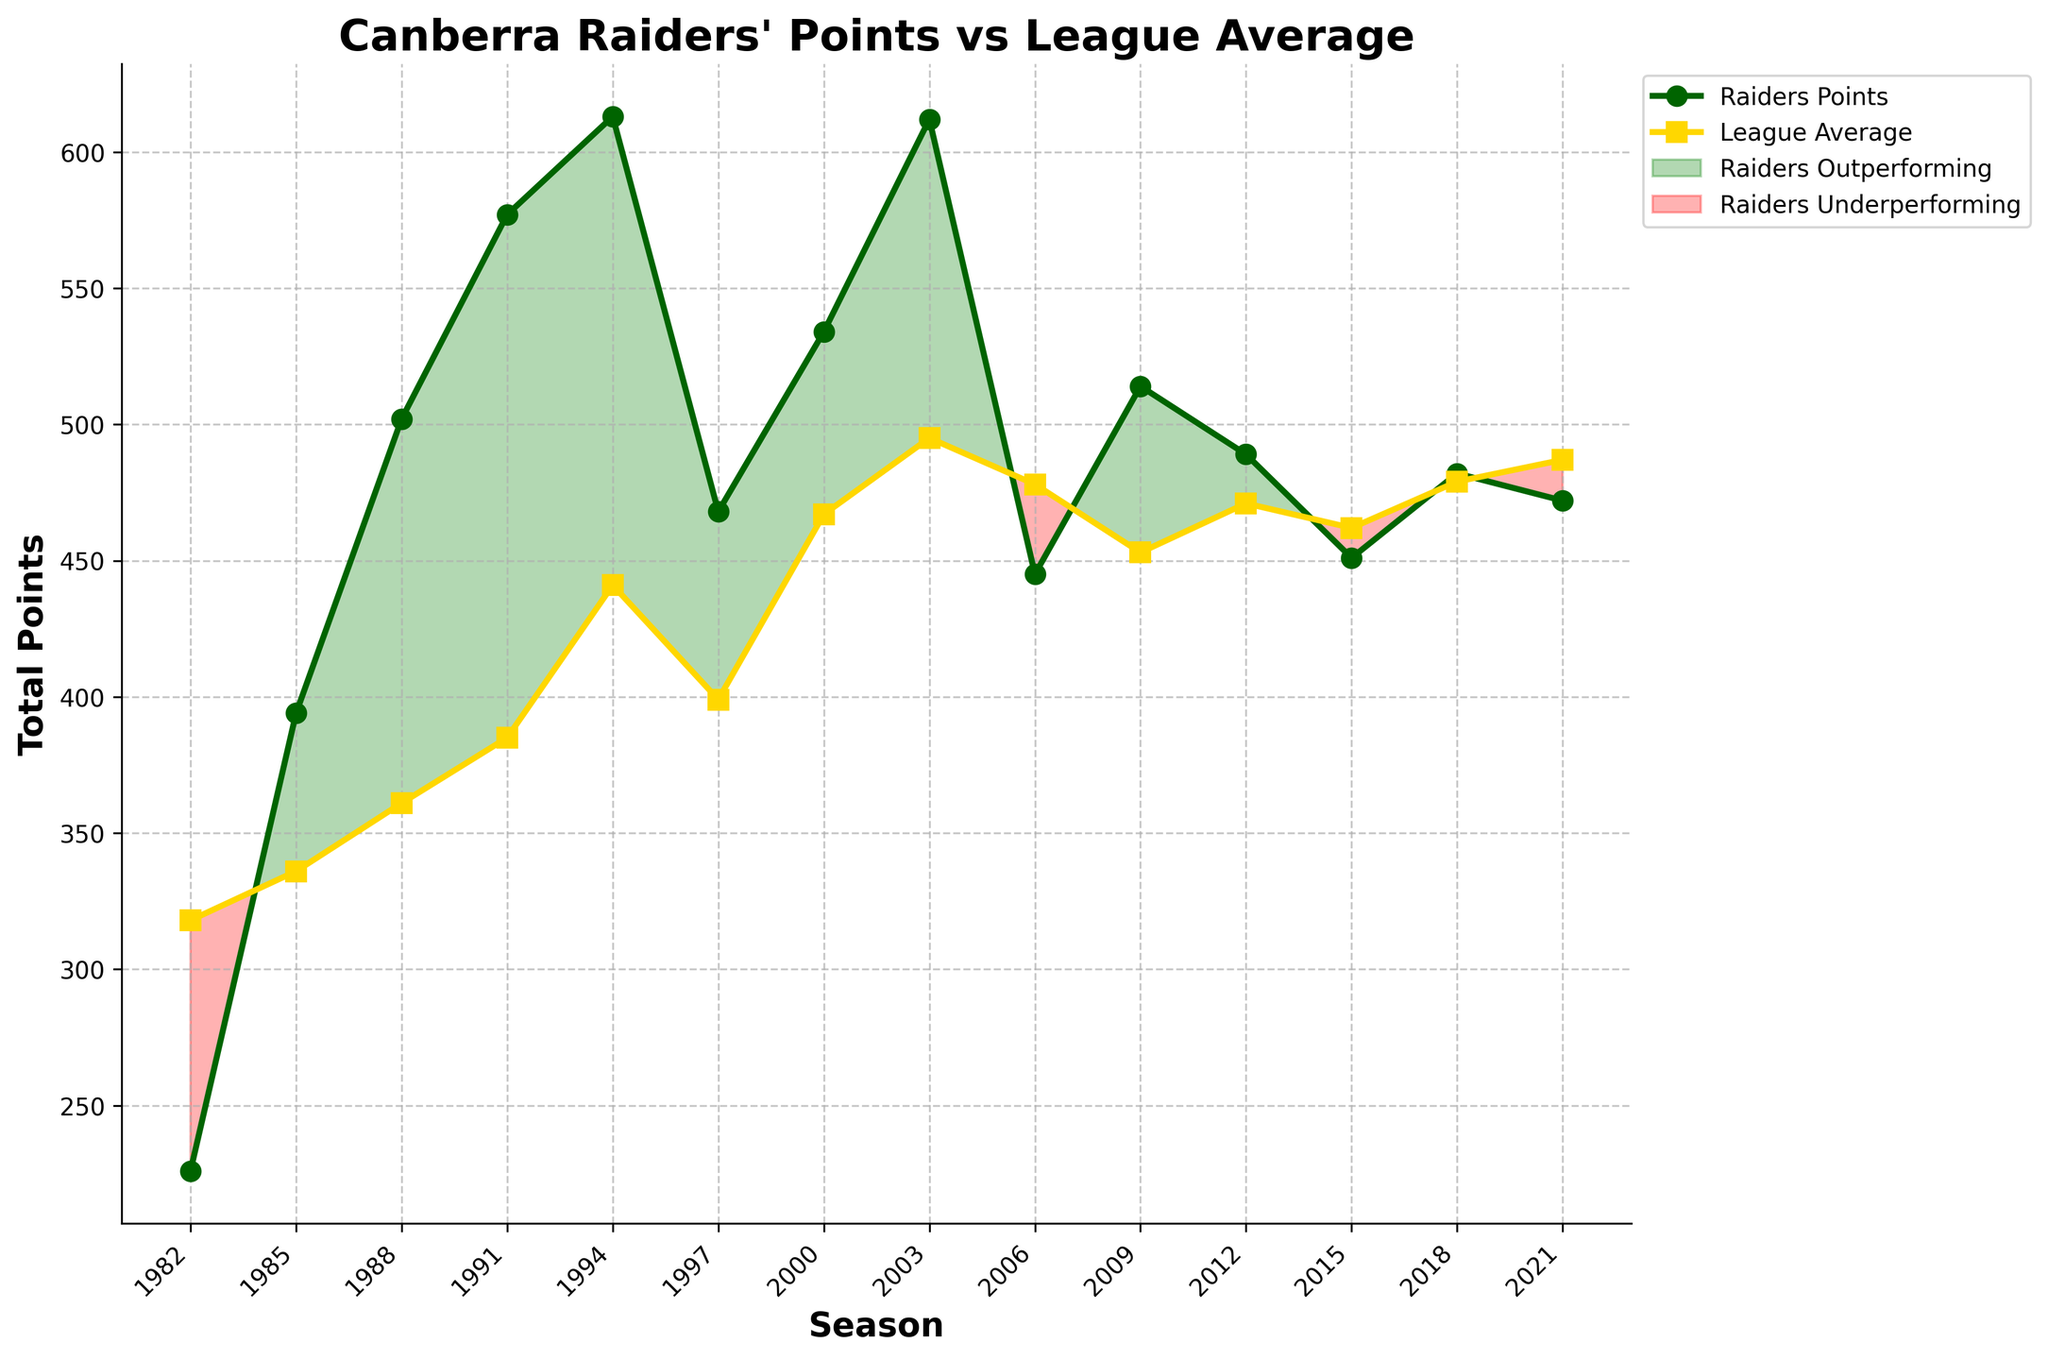What season did the Raiders score the most points? Look at the 'Raiders Points' line and identify the highest point on the graph. This occurs in the 1994 season.
Answer: 1994 In which season did the Raiders score significantly less than the league average? Look for seasons where the 'Raiders Points' line is notably below the 'League Average' line. This is most prominent in the 1982 season.
Answer: 1982 During which seasons did the Raiders outperform the league average? Identify periods where the 'Raiders Points' line is above the 'League Average' line. These include 1985, 1988, 1991, 1994, 2000, 2003, and 2009.
Answer: 1985, 1988, 1991, 1994, 2000, 2003, 2009 What trend can be observed in the Raiders' scoring since 2006? Observe the 'Raiders Points' line starting from the 2006 season onwards. The line shows fluctuations around the league average, never reaching significant peaks.
Answer: Fluctuating around league average How does the Raiders' total points in 2018 compare to their total points in 2015? Find the 'Raiders Points' values for 2018 and 2015, then calculate the difference (482 - 451).
Answer: 31 points higher in 2018 Which season features the smallest gap between the Raiders' points and league average? Determine the smallest vertical space between the 'Raiders Points' and 'League Average' lines. This occurs in 2021.
Answer: 2021 How many seasons did the Raiders score below the league average? Count the number of seasons where the 'Raiders Points' line is below the 'League Average' line. These seasons are 1982, 1997, 2006, 2012, 2015, 2018, 2021.
Answer: 7 seasons What is the average number of points scored by the Raiders across all the seasons? Sum the 'Raiders Points' for all seasons and divide by the number of seasons. The sum of Raiders Points is 6787, divided by 14 seasons, results in ~484.8.
Answer: ~484.8 In which seasons did the Raiders have more than 600 points? Locate points on the 'Raiders Points' line that are above 600. These seasons include 1994 and 2003.
Answer: 1994, 2003 How does the league average in 2021 compare to the Raiders' points in 2000? Locate the league average for 2021 and compare it to the Raiders' points in 2000. The values are 487 (2021 League Average) and 534 (2000 Raiders Points). The Raiders' points are higher in 2000.
Answer: Higher in 2000 